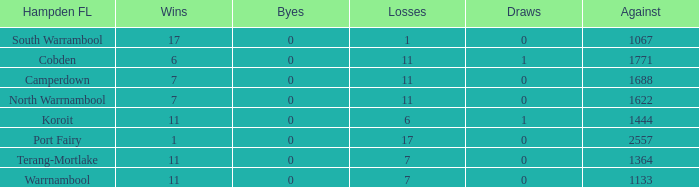What were the losses when the byes were less than 0? None. 